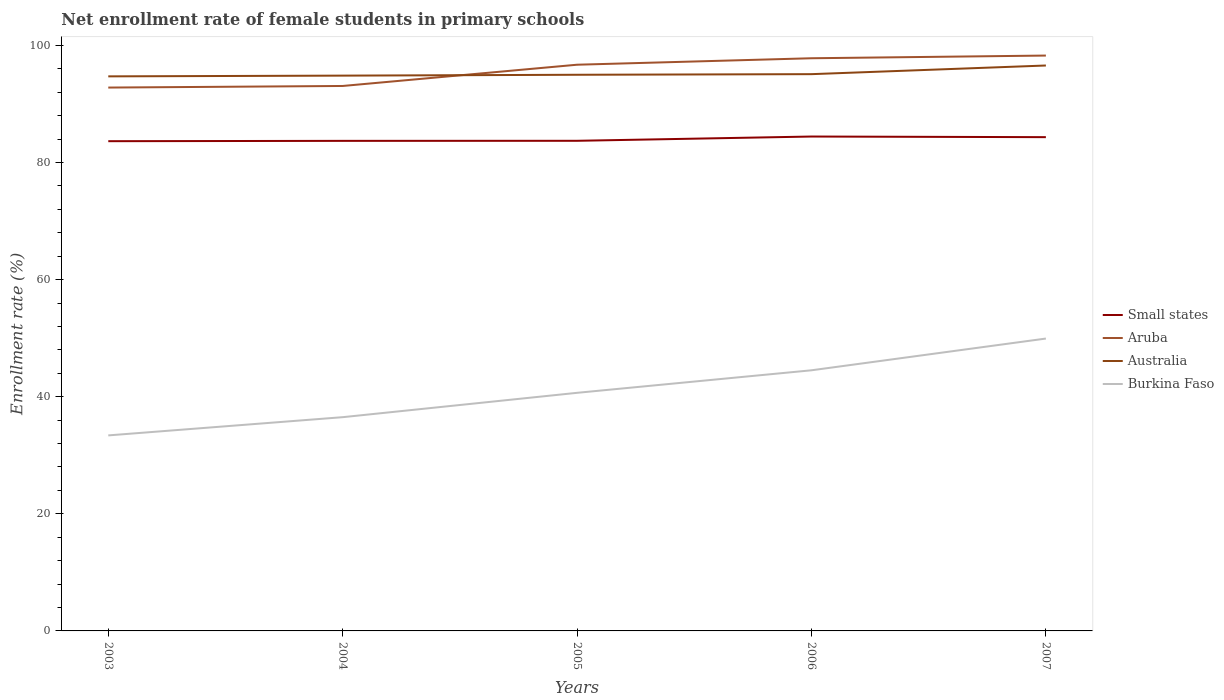Across all years, what is the maximum net enrollment rate of female students in primary schools in Aruba?
Ensure brevity in your answer.  92.81. In which year was the net enrollment rate of female students in primary schools in Small states maximum?
Provide a succinct answer. 2003. What is the total net enrollment rate of female students in primary schools in Australia in the graph?
Offer a terse response. -1.58. What is the difference between the highest and the second highest net enrollment rate of female students in primary schools in Burkina Faso?
Provide a short and direct response. 16.54. How many years are there in the graph?
Provide a succinct answer. 5. Does the graph contain grids?
Your answer should be compact. No. How many legend labels are there?
Make the answer very short. 4. What is the title of the graph?
Your response must be concise. Net enrollment rate of female students in primary schools. Does "Italy" appear as one of the legend labels in the graph?
Make the answer very short. No. What is the label or title of the Y-axis?
Offer a very short reply. Enrollment rate (%). What is the Enrollment rate (%) in Small states in 2003?
Provide a short and direct response. 83.65. What is the Enrollment rate (%) of Aruba in 2003?
Your answer should be very brief. 92.81. What is the Enrollment rate (%) of Australia in 2003?
Give a very brief answer. 94.73. What is the Enrollment rate (%) of Burkina Faso in 2003?
Ensure brevity in your answer.  33.4. What is the Enrollment rate (%) in Small states in 2004?
Provide a succinct answer. 83.71. What is the Enrollment rate (%) in Aruba in 2004?
Give a very brief answer. 93.08. What is the Enrollment rate (%) of Australia in 2004?
Provide a succinct answer. 94.85. What is the Enrollment rate (%) of Burkina Faso in 2004?
Ensure brevity in your answer.  36.51. What is the Enrollment rate (%) in Small states in 2005?
Provide a succinct answer. 83.72. What is the Enrollment rate (%) in Aruba in 2005?
Provide a succinct answer. 96.72. What is the Enrollment rate (%) of Australia in 2005?
Provide a succinct answer. 95. What is the Enrollment rate (%) of Burkina Faso in 2005?
Keep it short and to the point. 40.67. What is the Enrollment rate (%) in Small states in 2006?
Offer a very short reply. 84.45. What is the Enrollment rate (%) in Aruba in 2006?
Offer a very short reply. 97.82. What is the Enrollment rate (%) of Australia in 2006?
Offer a very short reply. 95.1. What is the Enrollment rate (%) in Burkina Faso in 2006?
Your answer should be compact. 44.52. What is the Enrollment rate (%) of Small states in 2007?
Provide a succinct answer. 84.34. What is the Enrollment rate (%) of Aruba in 2007?
Offer a terse response. 98.28. What is the Enrollment rate (%) in Australia in 2007?
Provide a short and direct response. 96.58. What is the Enrollment rate (%) in Burkina Faso in 2007?
Ensure brevity in your answer.  49.94. Across all years, what is the maximum Enrollment rate (%) of Small states?
Offer a terse response. 84.45. Across all years, what is the maximum Enrollment rate (%) in Aruba?
Your answer should be compact. 98.28. Across all years, what is the maximum Enrollment rate (%) in Australia?
Your answer should be compact. 96.58. Across all years, what is the maximum Enrollment rate (%) in Burkina Faso?
Keep it short and to the point. 49.94. Across all years, what is the minimum Enrollment rate (%) in Small states?
Keep it short and to the point. 83.65. Across all years, what is the minimum Enrollment rate (%) of Aruba?
Your response must be concise. 92.81. Across all years, what is the minimum Enrollment rate (%) in Australia?
Keep it short and to the point. 94.73. Across all years, what is the minimum Enrollment rate (%) of Burkina Faso?
Offer a terse response. 33.4. What is the total Enrollment rate (%) in Small states in the graph?
Provide a short and direct response. 419.87. What is the total Enrollment rate (%) in Aruba in the graph?
Your response must be concise. 478.71. What is the total Enrollment rate (%) of Australia in the graph?
Your answer should be very brief. 476.26. What is the total Enrollment rate (%) of Burkina Faso in the graph?
Your answer should be compact. 205.04. What is the difference between the Enrollment rate (%) in Small states in 2003 and that in 2004?
Keep it short and to the point. -0.06. What is the difference between the Enrollment rate (%) of Aruba in 2003 and that in 2004?
Your answer should be very brief. -0.27. What is the difference between the Enrollment rate (%) of Australia in 2003 and that in 2004?
Offer a terse response. -0.13. What is the difference between the Enrollment rate (%) of Burkina Faso in 2003 and that in 2004?
Provide a succinct answer. -3.11. What is the difference between the Enrollment rate (%) of Small states in 2003 and that in 2005?
Ensure brevity in your answer.  -0.07. What is the difference between the Enrollment rate (%) in Aruba in 2003 and that in 2005?
Give a very brief answer. -3.9. What is the difference between the Enrollment rate (%) in Australia in 2003 and that in 2005?
Your answer should be very brief. -0.27. What is the difference between the Enrollment rate (%) in Burkina Faso in 2003 and that in 2005?
Your answer should be very brief. -7.27. What is the difference between the Enrollment rate (%) of Small states in 2003 and that in 2006?
Provide a short and direct response. -0.79. What is the difference between the Enrollment rate (%) of Aruba in 2003 and that in 2006?
Offer a terse response. -5.01. What is the difference between the Enrollment rate (%) in Australia in 2003 and that in 2006?
Offer a very short reply. -0.38. What is the difference between the Enrollment rate (%) in Burkina Faso in 2003 and that in 2006?
Your answer should be very brief. -11.12. What is the difference between the Enrollment rate (%) of Small states in 2003 and that in 2007?
Give a very brief answer. -0.69. What is the difference between the Enrollment rate (%) of Aruba in 2003 and that in 2007?
Keep it short and to the point. -5.47. What is the difference between the Enrollment rate (%) of Australia in 2003 and that in 2007?
Make the answer very short. -1.86. What is the difference between the Enrollment rate (%) of Burkina Faso in 2003 and that in 2007?
Ensure brevity in your answer.  -16.54. What is the difference between the Enrollment rate (%) of Small states in 2004 and that in 2005?
Your answer should be compact. -0.01. What is the difference between the Enrollment rate (%) in Aruba in 2004 and that in 2005?
Provide a succinct answer. -3.63. What is the difference between the Enrollment rate (%) of Australia in 2004 and that in 2005?
Give a very brief answer. -0.15. What is the difference between the Enrollment rate (%) of Burkina Faso in 2004 and that in 2005?
Your response must be concise. -4.16. What is the difference between the Enrollment rate (%) in Small states in 2004 and that in 2006?
Offer a very short reply. -0.74. What is the difference between the Enrollment rate (%) of Aruba in 2004 and that in 2006?
Ensure brevity in your answer.  -4.74. What is the difference between the Enrollment rate (%) of Australia in 2004 and that in 2006?
Your response must be concise. -0.25. What is the difference between the Enrollment rate (%) in Burkina Faso in 2004 and that in 2006?
Your answer should be compact. -8.01. What is the difference between the Enrollment rate (%) in Small states in 2004 and that in 2007?
Keep it short and to the point. -0.63. What is the difference between the Enrollment rate (%) in Aruba in 2004 and that in 2007?
Make the answer very short. -5.19. What is the difference between the Enrollment rate (%) in Australia in 2004 and that in 2007?
Ensure brevity in your answer.  -1.73. What is the difference between the Enrollment rate (%) in Burkina Faso in 2004 and that in 2007?
Your response must be concise. -13.43. What is the difference between the Enrollment rate (%) of Small states in 2005 and that in 2006?
Your response must be concise. -0.73. What is the difference between the Enrollment rate (%) of Aruba in 2005 and that in 2006?
Your answer should be very brief. -1.1. What is the difference between the Enrollment rate (%) of Australia in 2005 and that in 2006?
Make the answer very short. -0.1. What is the difference between the Enrollment rate (%) of Burkina Faso in 2005 and that in 2006?
Your answer should be compact. -3.85. What is the difference between the Enrollment rate (%) in Small states in 2005 and that in 2007?
Your answer should be compact. -0.62. What is the difference between the Enrollment rate (%) of Aruba in 2005 and that in 2007?
Keep it short and to the point. -1.56. What is the difference between the Enrollment rate (%) in Australia in 2005 and that in 2007?
Provide a short and direct response. -1.58. What is the difference between the Enrollment rate (%) in Burkina Faso in 2005 and that in 2007?
Ensure brevity in your answer.  -9.27. What is the difference between the Enrollment rate (%) of Small states in 2006 and that in 2007?
Ensure brevity in your answer.  0.11. What is the difference between the Enrollment rate (%) of Aruba in 2006 and that in 2007?
Keep it short and to the point. -0.46. What is the difference between the Enrollment rate (%) of Australia in 2006 and that in 2007?
Your answer should be very brief. -1.48. What is the difference between the Enrollment rate (%) in Burkina Faso in 2006 and that in 2007?
Ensure brevity in your answer.  -5.42. What is the difference between the Enrollment rate (%) of Small states in 2003 and the Enrollment rate (%) of Aruba in 2004?
Provide a succinct answer. -9.43. What is the difference between the Enrollment rate (%) in Small states in 2003 and the Enrollment rate (%) in Australia in 2004?
Your response must be concise. -11.2. What is the difference between the Enrollment rate (%) of Small states in 2003 and the Enrollment rate (%) of Burkina Faso in 2004?
Provide a succinct answer. 47.14. What is the difference between the Enrollment rate (%) in Aruba in 2003 and the Enrollment rate (%) in Australia in 2004?
Offer a terse response. -2.04. What is the difference between the Enrollment rate (%) in Aruba in 2003 and the Enrollment rate (%) in Burkina Faso in 2004?
Ensure brevity in your answer.  56.3. What is the difference between the Enrollment rate (%) in Australia in 2003 and the Enrollment rate (%) in Burkina Faso in 2004?
Keep it short and to the point. 58.22. What is the difference between the Enrollment rate (%) of Small states in 2003 and the Enrollment rate (%) of Aruba in 2005?
Your answer should be compact. -13.06. What is the difference between the Enrollment rate (%) of Small states in 2003 and the Enrollment rate (%) of Australia in 2005?
Provide a short and direct response. -11.34. What is the difference between the Enrollment rate (%) in Small states in 2003 and the Enrollment rate (%) in Burkina Faso in 2005?
Your response must be concise. 42.98. What is the difference between the Enrollment rate (%) of Aruba in 2003 and the Enrollment rate (%) of Australia in 2005?
Offer a terse response. -2.19. What is the difference between the Enrollment rate (%) of Aruba in 2003 and the Enrollment rate (%) of Burkina Faso in 2005?
Your answer should be very brief. 52.14. What is the difference between the Enrollment rate (%) of Australia in 2003 and the Enrollment rate (%) of Burkina Faso in 2005?
Give a very brief answer. 54.06. What is the difference between the Enrollment rate (%) in Small states in 2003 and the Enrollment rate (%) in Aruba in 2006?
Provide a succinct answer. -14.17. What is the difference between the Enrollment rate (%) of Small states in 2003 and the Enrollment rate (%) of Australia in 2006?
Keep it short and to the point. -11.45. What is the difference between the Enrollment rate (%) in Small states in 2003 and the Enrollment rate (%) in Burkina Faso in 2006?
Your answer should be compact. 39.13. What is the difference between the Enrollment rate (%) of Aruba in 2003 and the Enrollment rate (%) of Australia in 2006?
Keep it short and to the point. -2.29. What is the difference between the Enrollment rate (%) of Aruba in 2003 and the Enrollment rate (%) of Burkina Faso in 2006?
Give a very brief answer. 48.29. What is the difference between the Enrollment rate (%) of Australia in 2003 and the Enrollment rate (%) of Burkina Faso in 2006?
Keep it short and to the point. 50.21. What is the difference between the Enrollment rate (%) in Small states in 2003 and the Enrollment rate (%) in Aruba in 2007?
Provide a succinct answer. -14.62. What is the difference between the Enrollment rate (%) in Small states in 2003 and the Enrollment rate (%) in Australia in 2007?
Provide a short and direct response. -12.93. What is the difference between the Enrollment rate (%) in Small states in 2003 and the Enrollment rate (%) in Burkina Faso in 2007?
Give a very brief answer. 33.71. What is the difference between the Enrollment rate (%) of Aruba in 2003 and the Enrollment rate (%) of Australia in 2007?
Give a very brief answer. -3.77. What is the difference between the Enrollment rate (%) in Aruba in 2003 and the Enrollment rate (%) in Burkina Faso in 2007?
Your answer should be very brief. 42.87. What is the difference between the Enrollment rate (%) in Australia in 2003 and the Enrollment rate (%) in Burkina Faso in 2007?
Offer a terse response. 44.79. What is the difference between the Enrollment rate (%) of Small states in 2004 and the Enrollment rate (%) of Aruba in 2005?
Your answer should be very brief. -13.01. What is the difference between the Enrollment rate (%) of Small states in 2004 and the Enrollment rate (%) of Australia in 2005?
Provide a short and direct response. -11.29. What is the difference between the Enrollment rate (%) of Small states in 2004 and the Enrollment rate (%) of Burkina Faso in 2005?
Provide a succinct answer. 43.04. What is the difference between the Enrollment rate (%) in Aruba in 2004 and the Enrollment rate (%) in Australia in 2005?
Your answer should be compact. -1.91. What is the difference between the Enrollment rate (%) of Aruba in 2004 and the Enrollment rate (%) of Burkina Faso in 2005?
Your answer should be compact. 52.41. What is the difference between the Enrollment rate (%) of Australia in 2004 and the Enrollment rate (%) of Burkina Faso in 2005?
Ensure brevity in your answer.  54.18. What is the difference between the Enrollment rate (%) of Small states in 2004 and the Enrollment rate (%) of Aruba in 2006?
Keep it short and to the point. -14.11. What is the difference between the Enrollment rate (%) of Small states in 2004 and the Enrollment rate (%) of Australia in 2006?
Your response must be concise. -11.39. What is the difference between the Enrollment rate (%) of Small states in 2004 and the Enrollment rate (%) of Burkina Faso in 2006?
Offer a terse response. 39.19. What is the difference between the Enrollment rate (%) of Aruba in 2004 and the Enrollment rate (%) of Australia in 2006?
Ensure brevity in your answer.  -2.02. What is the difference between the Enrollment rate (%) of Aruba in 2004 and the Enrollment rate (%) of Burkina Faso in 2006?
Offer a terse response. 48.57. What is the difference between the Enrollment rate (%) of Australia in 2004 and the Enrollment rate (%) of Burkina Faso in 2006?
Your answer should be compact. 50.33. What is the difference between the Enrollment rate (%) of Small states in 2004 and the Enrollment rate (%) of Aruba in 2007?
Offer a terse response. -14.57. What is the difference between the Enrollment rate (%) in Small states in 2004 and the Enrollment rate (%) in Australia in 2007?
Give a very brief answer. -12.87. What is the difference between the Enrollment rate (%) in Small states in 2004 and the Enrollment rate (%) in Burkina Faso in 2007?
Give a very brief answer. 33.77. What is the difference between the Enrollment rate (%) in Aruba in 2004 and the Enrollment rate (%) in Australia in 2007?
Offer a very short reply. -3.5. What is the difference between the Enrollment rate (%) of Aruba in 2004 and the Enrollment rate (%) of Burkina Faso in 2007?
Offer a very short reply. 43.15. What is the difference between the Enrollment rate (%) in Australia in 2004 and the Enrollment rate (%) in Burkina Faso in 2007?
Offer a very short reply. 44.91. What is the difference between the Enrollment rate (%) of Small states in 2005 and the Enrollment rate (%) of Aruba in 2006?
Provide a short and direct response. -14.1. What is the difference between the Enrollment rate (%) of Small states in 2005 and the Enrollment rate (%) of Australia in 2006?
Give a very brief answer. -11.38. What is the difference between the Enrollment rate (%) of Small states in 2005 and the Enrollment rate (%) of Burkina Faso in 2006?
Offer a very short reply. 39.2. What is the difference between the Enrollment rate (%) in Aruba in 2005 and the Enrollment rate (%) in Australia in 2006?
Offer a terse response. 1.61. What is the difference between the Enrollment rate (%) of Aruba in 2005 and the Enrollment rate (%) of Burkina Faso in 2006?
Your answer should be very brief. 52.2. What is the difference between the Enrollment rate (%) of Australia in 2005 and the Enrollment rate (%) of Burkina Faso in 2006?
Your answer should be compact. 50.48. What is the difference between the Enrollment rate (%) in Small states in 2005 and the Enrollment rate (%) in Aruba in 2007?
Your answer should be very brief. -14.56. What is the difference between the Enrollment rate (%) in Small states in 2005 and the Enrollment rate (%) in Australia in 2007?
Offer a very short reply. -12.86. What is the difference between the Enrollment rate (%) of Small states in 2005 and the Enrollment rate (%) of Burkina Faso in 2007?
Give a very brief answer. 33.78. What is the difference between the Enrollment rate (%) in Aruba in 2005 and the Enrollment rate (%) in Australia in 2007?
Your answer should be very brief. 0.13. What is the difference between the Enrollment rate (%) of Aruba in 2005 and the Enrollment rate (%) of Burkina Faso in 2007?
Offer a terse response. 46.78. What is the difference between the Enrollment rate (%) in Australia in 2005 and the Enrollment rate (%) in Burkina Faso in 2007?
Your response must be concise. 45.06. What is the difference between the Enrollment rate (%) in Small states in 2006 and the Enrollment rate (%) in Aruba in 2007?
Give a very brief answer. -13.83. What is the difference between the Enrollment rate (%) in Small states in 2006 and the Enrollment rate (%) in Australia in 2007?
Provide a short and direct response. -12.13. What is the difference between the Enrollment rate (%) in Small states in 2006 and the Enrollment rate (%) in Burkina Faso in 2007?
Give a very brief answer. 34.51. What is the difference between the Enrollment rate (%) of Aruba in 2006 and the Enrollment rate (%) of Australia in 2007?
Provide a short and direct response. 1.24. What is the difference between the Enrollment rate (%) of Aruba in 2006 and the Enrollment rate (%) of Burkina Faso in 2007?
Your response must be concise. 47.88. What is the difference between the Enrollment rate (%) in Australia in 2006 and the Enrollment rate (%) in Burkina Faso in 2007?
Give a very brief answer. 45.16. What is the average Enrollment rate (%) in Small states per year?
Give a very brief answer. 83.97. What is the average Enrollment rate (%) in Aruba per year?
Provide a succinct answer. 95.74. What is the average Enrollment rate (%) in Australia per year?
Your answer should be compact. 95.25. What is the average Enrollment rate (%) of Burkina Faso per year?
Your response must be concise. 41.01. In the year 2003, what is the difference between the Enrollment rate (%) of Small states and Enrollment rate (%) of Aruba?
Offer a very short reply. -9.16. In the year 2003, what is the difference between the Enrollment rate (%) of Small states and Enrollment rate (%) of Australia?
Keep it short and to the point. -11.07. In the year 2003, what is the difference between the Enrollment rate (%) in Small states and Enrollment rate (%) in Burkina Faso?
Ensure brevity in your answer.  50.26. In the year 2003, what is the difference between the Enrollment rate (%) in Aruba and Enrollment rate (%) in Australia?
Keep it short and to the point. -1.91. In the year 2003, what is the difference between the Enrollment rate (%) of Aruba and Enrollment rate (%) of Burkina Faso?
Your answer should be compact. 59.41. In the year 2003, what is the difference between the Enrollment rate (%) of Australia and Enrollment rate (%) of Burkina Faso?
Keep it short and to the point. 61.33. In the year 2004, what is the difference between the Enrollment rate (%) in Small states and Enrollment rate (%) in Aruba?
Give a very brief answer. -9.37. In the year 2004, what is the difference between the Enrollment rate (%) in Small states and Enrollment rate (%) in Australia?
Ensure brevity in your answer.  -11.14. In the year 2004, what is the difference between the Enrollment rate (%) in Small states and Enrollment rate (%) in Burkina Faso?
Keep it short and to the point. 47.2. In the year 2004, what is the difference between the Enrollment rate (%) in Aruba and Enrollment rate (%) in Australia?
Offer a very short reply. -1.77. In the year 2004, what is the difference between the Enrollment rate (%) in Aruba and Enrollment rate (%) in Burkina Faso?
Make the answer very short. 56.57. In the year 2004, what is the difference between the Enrollment rate (%) of Australia and Enrollment rate (%) of Burkina Faso?
Provide a succinct answer. 58.34. In the year 2005, what is the difference between the Enrollment rate (%) in Small states and Enrollment rate (%) in Aruba?
Your response must be concise. -13. In the year 2005, what is the difference between the Enrollment rate (%) in Small states and Enrollment rate (%) in Australia?
Provide a succinct answer. -11.28. In the year 2005, what is the difference between the Enrollment rate (%) in Small states and Enrollment rate (%) in Burkina Faso?
Give a very brief answer. 43.05. In the year 2005, what is the difference between the Enrollment rate (%) in Aruba and Enrollment rate (%) in Australia?
Ensure brevity in your answer.  1.72. In the year 2005, what is the difference between the Enrollment rate (%) in Aruba and Enrollment rate (%) in Burkina Faso?
Provide a short and direct response. 56.04. In the year 2005, what is the difference between the Enrollment rate (%) in Australia and Enrollment rate (%) in Burkina Faso?
Provide a short and direct response. 54.33. In the year 2006, what is the difference between the Enrollment rate (%) in Small states and Enrollment rate (%) in Aruba?
Offer a very short reply. -13.37. In the year 2006, what is the difference between the Enrollment rate (%) in Small states and Enrollment rate (%) in Australia?
Make the answer very short. -10.65. In the year 2006, what is the difference between the Enrollment rate (%) of Small states and Enrollment rate (%) of Burkina Faso?
Your response must be concise. 39.93. In the year 2006, what is the difference between the Enrollment rate (%) of Aruba and Enrollment rate (%) of Australia?
Your answer should be very brief. 2.72. In the year 2006, what is the difference between the Enrollment rate (%) of Aruba and Enrollment rate (%) of Burkina Faso?
Your answer should be very brief. 53.3. In the year 2006, what is the difference between the Enrollment rate (%) in Australia and Enrollment rate (%) in Burkina Faso?
Your answer should be very brief. 50.58. In the year 2007, what is the difference between the Enrollment rate (%) in Small states and Enrollment rate (%) in Aruba?
Offer a very short reply. -13.94. In the year 2007, what is the difference between the Enrollment rate (%) in Small states and Enrollment rate (%) in Australia?
Give a very brief answer. -12.24. In the year 2007, what is the difference between the Enrollment rate (%) in Small states and Enrollment rate (%) in Burkina Faso?
Provide a short and direct response. 34.4. In the year 2007, what is the difference between the Enrollment rate (%) of Aruba and Enrollment rate (%) of Australia?
Offer a terse response. 1.7. In the year 2007, what is the difference between the Enrollment rate (%) of Aruba and Enrollment rate (%) of Burkina Faso?
Your answer should be compact. 48.34. In the year 2007, what is the difference between the Enrollment rate (%) in Australia and Enrollment rate (%) in Burkina Faso?
Make the answer very short. 46.64. What is the ratio of the Enrollment rate (%) of Small states in 2003 to that in 2004?
Give a very brief answer. 1. What is the ratio of the Enrollment rate (%) in Australia in 2003 to that in 2004?
Keep it short and to the point. 1. What is the ratio of the Enrollment rate (%) in Burkina Faso in 2003 to that in 2004?
Provide a short and direct response. 0.91. What is the ratio of the Enrollment rate (%) in Aruba in 2003 to that in 2005?
Offer a terse response. 0.96. What is the ratio of the Enrollment rate (%) of Australia in 2003 to that in 2005?
Provide a short and direct response. 1. What is the ratio of the Enrollment rate (%) in Burkina Faso in 2003 to that in 2005?
Keep it short and to the point. 0.82. What is the ratio of the Enrollment rate (%) of Small states in 2003 to that in 2006?
Your answer should be compact. 0.99. What is the ratio of the Enrollment rate (%) in Aruba in 2003 to that in 2006?
Your answer should be very brief. 0.95. What is the ratio of the Enrollment rate (%) of Australia in 2003 to that in 2006?
Your response must be concise. 1. What is the ratio of the Enrollment rate (%) of Burkina Faso in 2003 to that in 2006?
Provide a short and direct response. 0.75. What is the ratio of the Enrollment rate (%) of Small states in 2003 to that in 2007?
Give a very brief answer. 0.99. What is the ratio of the Enrollment rate (%) in Australia in 2003 to that in 2007?
Give a very brief answer. 0.98. What is the ratio of the Enrollment rate (%) of Burkina Faso in 2003 to that in 2007?
Your answer should be compact. 0.67. What is the ratio of the Enrollment rate (%) of Aruba in 2004 to that in 2005?
Your answer should be compact. 0.96. What is the ratio of the Enrollment rate (%) of Burkina Faso in 2004 to that in 2005?
Keep it short and to the point. 0.9. What is the ratio of the Enrollment rate (%) of Small states in 2004 to that in 2006?
Your response must be concise. 0.99. What is the ratio of the Enrollment rate (%) of Aruba in 2004 to that in 2006?
Offer a terse response. 0.95. What is the ratio of the Enrollment rate (%) in Burkina Faso in 2004 to that in 2006?
Provide a succinct answer. 0.82. What is the ratio of the Enrollment rate (%) in Aruba in 2004 to that in 2007?
Your answer should be compact. 0.95. What is the ratio of the Enrollment rate (%) of Australia in 2004 to that in 2007?
Your response must be concise. 0.98. What is the ratio of the Enrollment rate (%) in Burkina Faso in 2004 to that in 2007?
Make the answer very short. 0.73. What is the ratio of the Enrollment rate (%) in Small states in 2005 to that in 2006?
Your answer should be compact. 0.99. What is the ratio of the Enrollment rate (%) in Aruba in 2005 to that in 2006?
Offer a very short reply. 0.99. What is the ratio of the Enrollment rate (%) in Burkina Faso in 2005 to that in 2006?
Your answer should be very brief. 0.91. What is the ratio of the Enrollment rate (%) in Aruba in 2005 to that in 2007?
Your answer should be very brief. 0.98. What is the ratio of the Enrollment rate (%) in Australia in 2005 to that in 2007?
Offer a very short reply. 0.98. What is the ratio of the Enrollment rate (%) of Burkina Faso in 2005 to that in 2007?
Provide a succinct answer. 0.81. What is the ratio of the Enrollment rate (%) in Small states in 2006 to that in 2007?
Your answer should be very brief. 1. What is the ratio of the Enrollment rate (%) of Aruba in 2006 to that in 2007?
Your answer should be very brief. 1. What is the ratio of the Enrollment rate (%) of Australia in 2006 to that in 2007?
Offer a terse response. 0.98. What is the ratio of the Enrollment rate (%) of Burkina Faso in 2006 to that in 2007?
Your answer should be very brief. 0.89. What is the difference between the highest and the second highest Enrollment rate (%) of Small states?
Ensure brevity in your answer.  0.11. What is the difference between the highest and the second highest Enrollment rate (%) in Aruba?
Offer a terse response. 0.46. What is the difference between the highest and the second highest Enrollment rate (%) in Australia?
Offer a terse response. 1.48. What is the difference between the highest and the second highest Enrollment rate (%) of Burkina Faso?
Your answer should be compact. 5.42. What is the difference between the highest and the lowest Enrollment rate (%) in Small states?
Provide a short and direct response. 0.79. What is the difference between the highest and the lowest Enrollment rate (%) of Aruba?
Provide a succinct answer. 5.47. What is the difference between the highest and the lowest Enrollment rate (%) of Australia?
Your answer should be very brief. 1.86. What is the difference between the highest and the lowest Enrollment rate (%) of Burkina Faso?
Give a very brief answer. 16.54. 